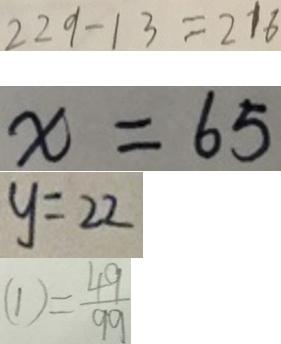<formula> <loc_0><loc_0><loc_500><loc_500>2 2 9 - 1 3 = 2 1 6 
 x = 6 5 
 y = 2 2 
 ( 1 ) = \frac { 4 9 } { 9 9 }</formula> 